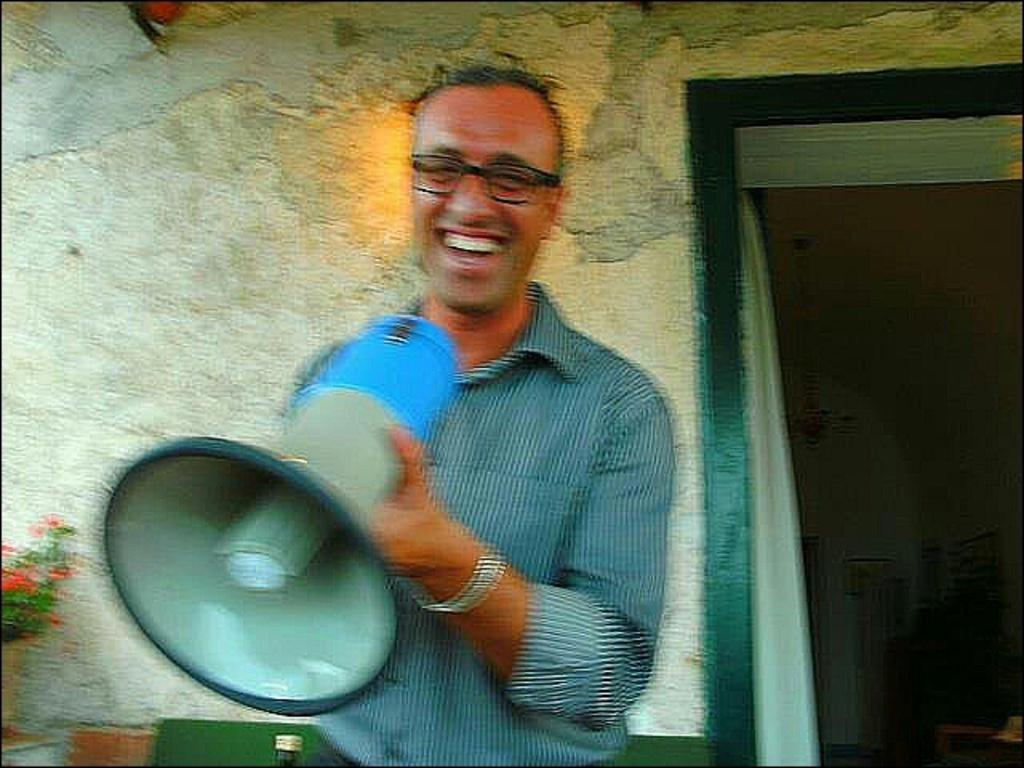What is the man in the image doing? The man is standing in the image and holding a loudspeaker mic in his hand. What can be seen in the image besides the man? There are flowers in a vase in the image. What is the background of the image? There is a wall visible in the image. What type of engine is powering the coil in the image? There is no engine or coil present in the image. 